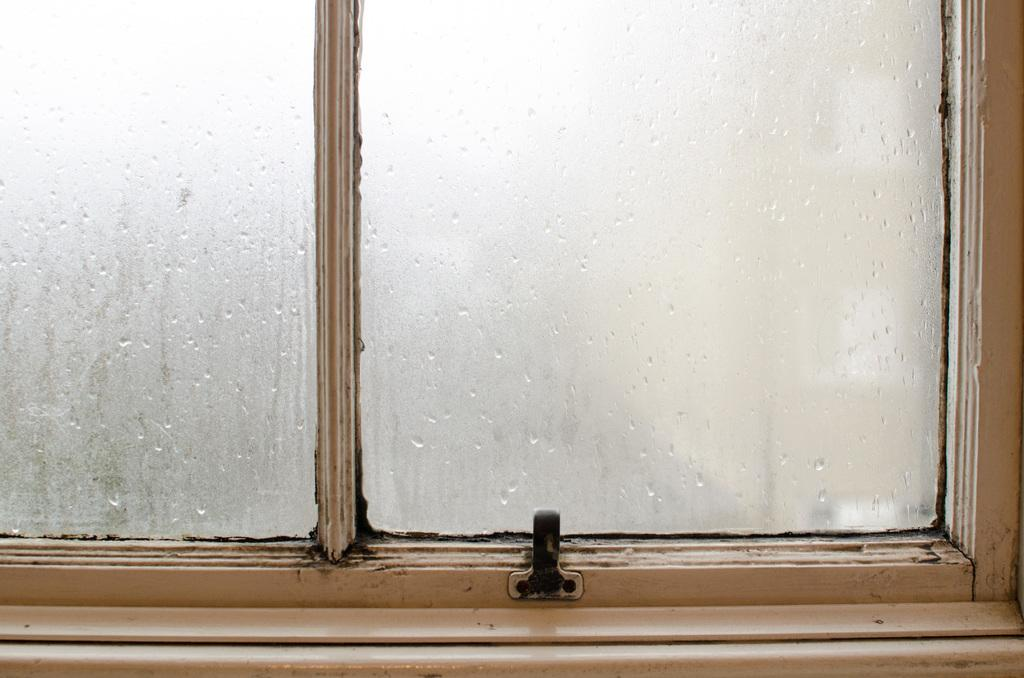What can be seen in the image that allows light to enter a room? There is a window in the image. What material is used for the window's panels? The window has glass panels. What is present on the glass panels in the image? There are water droplets on the glass. What type of bed is visible in the image? There is no bed present in the image; it only features a window with water droplets on the glass. 